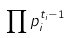Convert formula to latex. <formula><loc_0><loc_0><loc_500><loc_500>\prod p _ { i } ^ { t _ { i } - 1 }</formula> 